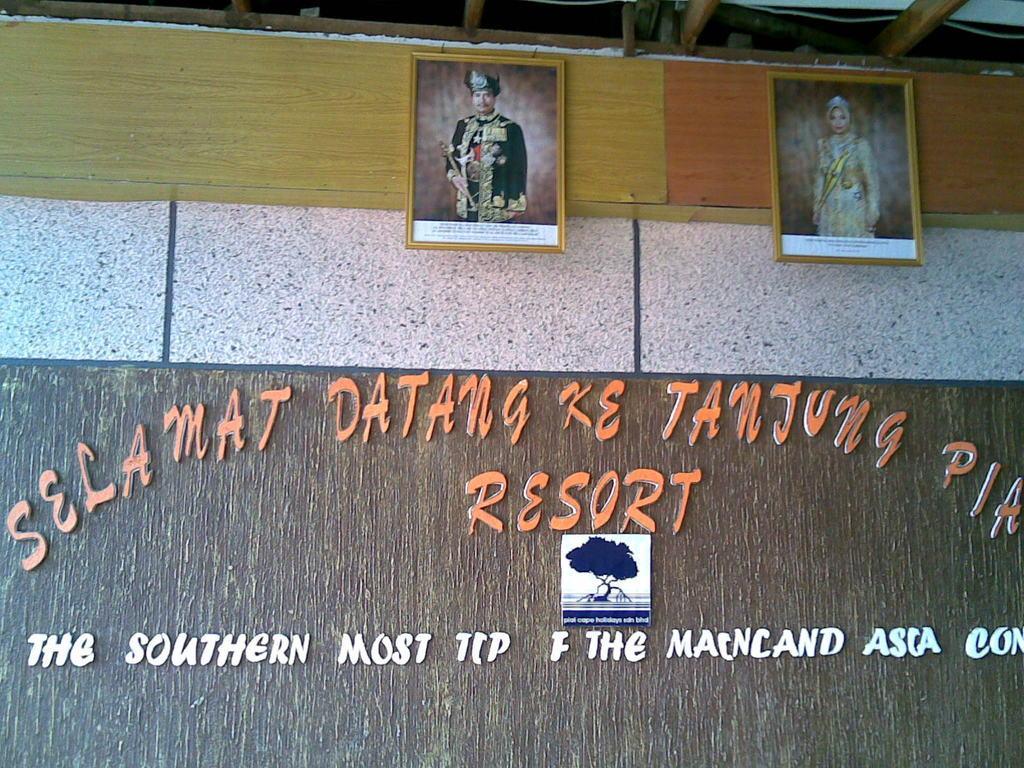In one or two sentences, can you explain what this image depicts? In the background we can see the wall. In this picture we can see the frames, board and text on the wall. At the top we can see a wire and wooden objects. 